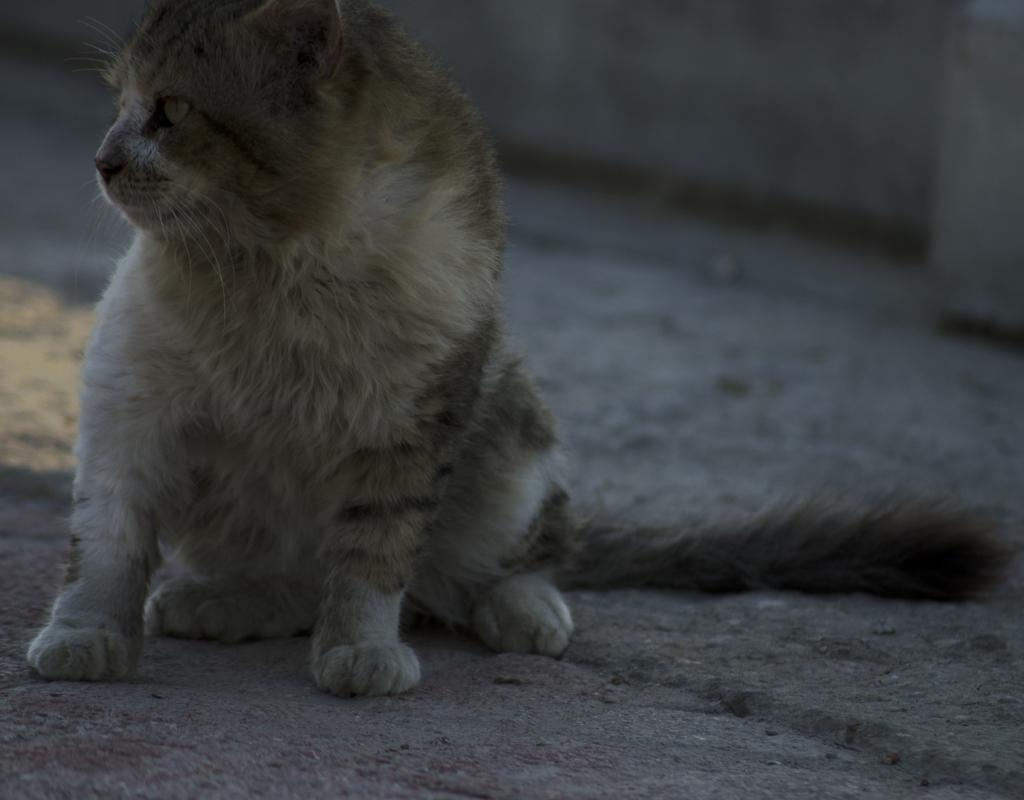What type of animal is in the image? There is a cat in the image. Where is the cat located in the image? The cat is on the ground. What can be seen in the background of the image? There is a wall visible in the background of the image. How many hands does the cat have in the image? Cats do not have hands; they have paws. --- Facts: 1. There is a person holding a camera in the image. 2. The person is standing on a bridge. 3. There is a river visible below the bridge. 4. The sky is visible in the background of the image. Absurd Topics: elephant, bicycle, ocean Conversation: What is the person in the image holding? The person is holding a camera in the image. Where is the person located in the image? The person is standing on a bridge. What can be seen below the bridge in the image? There is a river visible below the bridge. What is visible in the background of the image? The sky is visible in the background of the image. Reasoning: Let's think step by step in order to produce the conversation. We start by identifying the main subject in the image, which is the person holding a camera. Then, we describe the person's location, which is on a bridge. Next, we mention the river visible below the bridge. Finally, we describe the background element, which is the sky. Each question is designed to elicit a specific detail about the image that is known from the provided facts. Absurd Question/Answer: Can you see an elephant swimming in the ocean in the image? No, there is no elephant or ocean present in the image. 